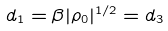<formula> <loc_0><loc_0><loc_500><loc_500>d _ { 1 } = \beta | \rho _ { 0 } | ^ { 1 / 2 } = d _ { 3 }</formula> 